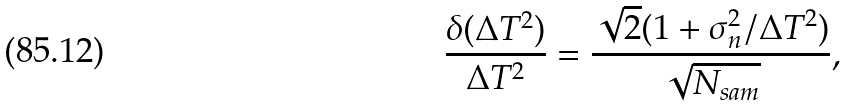Convert formula to latex. <formula><loc_0><loc_0><loc_500><loc_500>\frac { \delta ( \Delta T ^ { 2 } ) } { \Delta T ^ { 2 } } = \frac { \sqrt { 2 } ( 1 + \sigma _ { n } ^ { 2 } / \Delta T ^ { 2 } ) } { \sqrt { N _ { s a m } } } ,</formula> 